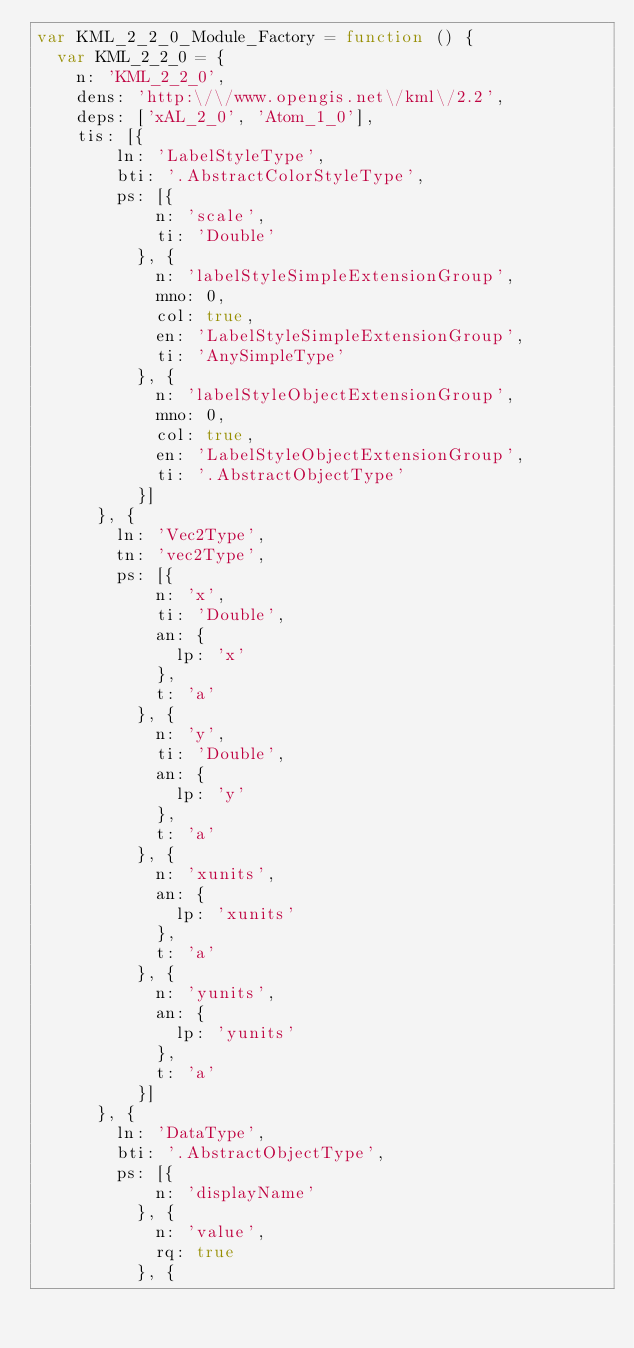Convert code to text. <code><loc_0><loc_0><loc_500><loc_500><_JavaScript_>var KML_2_2_0_Module_Factory = function () {
  var KML_2_2_0 = {
    n: 'KML_2_2_0',
    dens: 'http:\/\/www.opengis.net\/kml\/2.2',
    deps: ['xAL_2_0', 'Atom_1_0'],
    tis: [{
        ln: 'LabelStyleType',
        bti: '.AbstractColorStyleType',
        ps: [{
            n: 'scale',
            ti: 'Double'
          }, {
            n: 'labelStyleSimpleExtensionGroup',
            mno: 0,
            col: true,
            en: 'LabelStyleSimpleExtensionGroup',
            ti: 'AnySimpleType'
          }, {
            n: 'labelStyleObjectExtensionGroup',
            mno: 0,
            col: true,
            en: 'LabelStyleObjectExtensionGroup',
            ti: '.AbstractObjectType'
          }]
      }, {
        ln: 'Vec2Type',
        tn: 'vec2Type',
        ps: [{
            n: 'x',
            ti: 'Double',
            an: {
              lp: 'x'
            },
            t: 'a'
          }, {
            n: 'y',
            ti: 'Double',
            an: {
              lp: 'y'
            },
            t: 'a'
          }, {
            n: 'xunits',
            an: {
              lp: 'xunits'
            },
            t: 'a'
          }, {
            n: 'yunits',
            an: {
              lp: 'yunits'
            },
            t: 'a'
          }]
      }, {
        ln: 'DataType',
        bti: '.AbstractObjectType',
        ps: [{
            n: 'displayName'
          }, {
            n: 'value',
            rq: true
          }, {</code> 